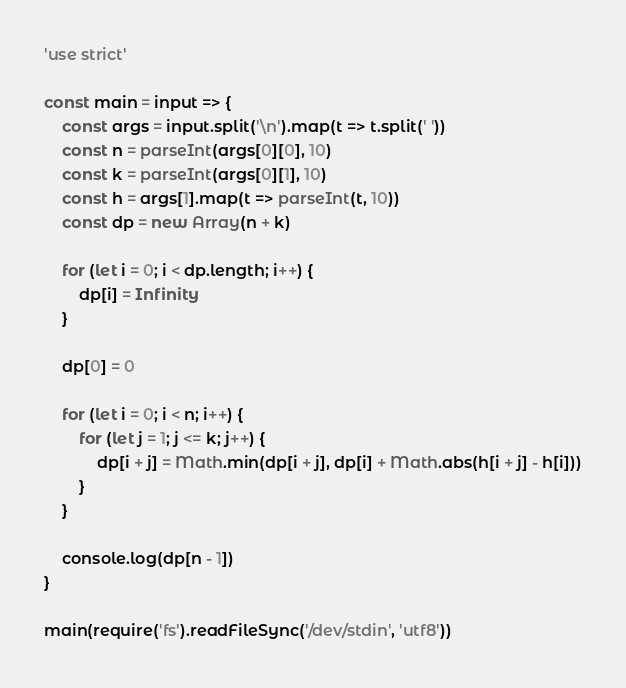Convert code to text. <code><loc_0><loc_0><loc_500><loc_500><_JavaScript_>'use strict'

const main = input => {
	const args = input.split('\n').map(t => t.split(' '))
	const n = parseInt(args[0][0], 10)
	const k = parseInt(args[0][1], 10)
	const h = args[1].map(t => parseInt(t, 10))
	const dp = new Array(n + k)

	for (let i = 0; i < dp.length; i++) {
		dp[i] = Infinity
	}

	dp[0] = 0

	for (let i = 0; i < n; i++) {
		for (let j = 1; j <= k; j++) {
			dp[i + j] = Math.min(dp[i + j], dp[i] + Math.abs(h[i + j] - h[i]))
		}
	}

	console.log(dp[n - 1])
}

main(require('fs').readFileSync('/dev/stdin', 'utf8'))
</code> 